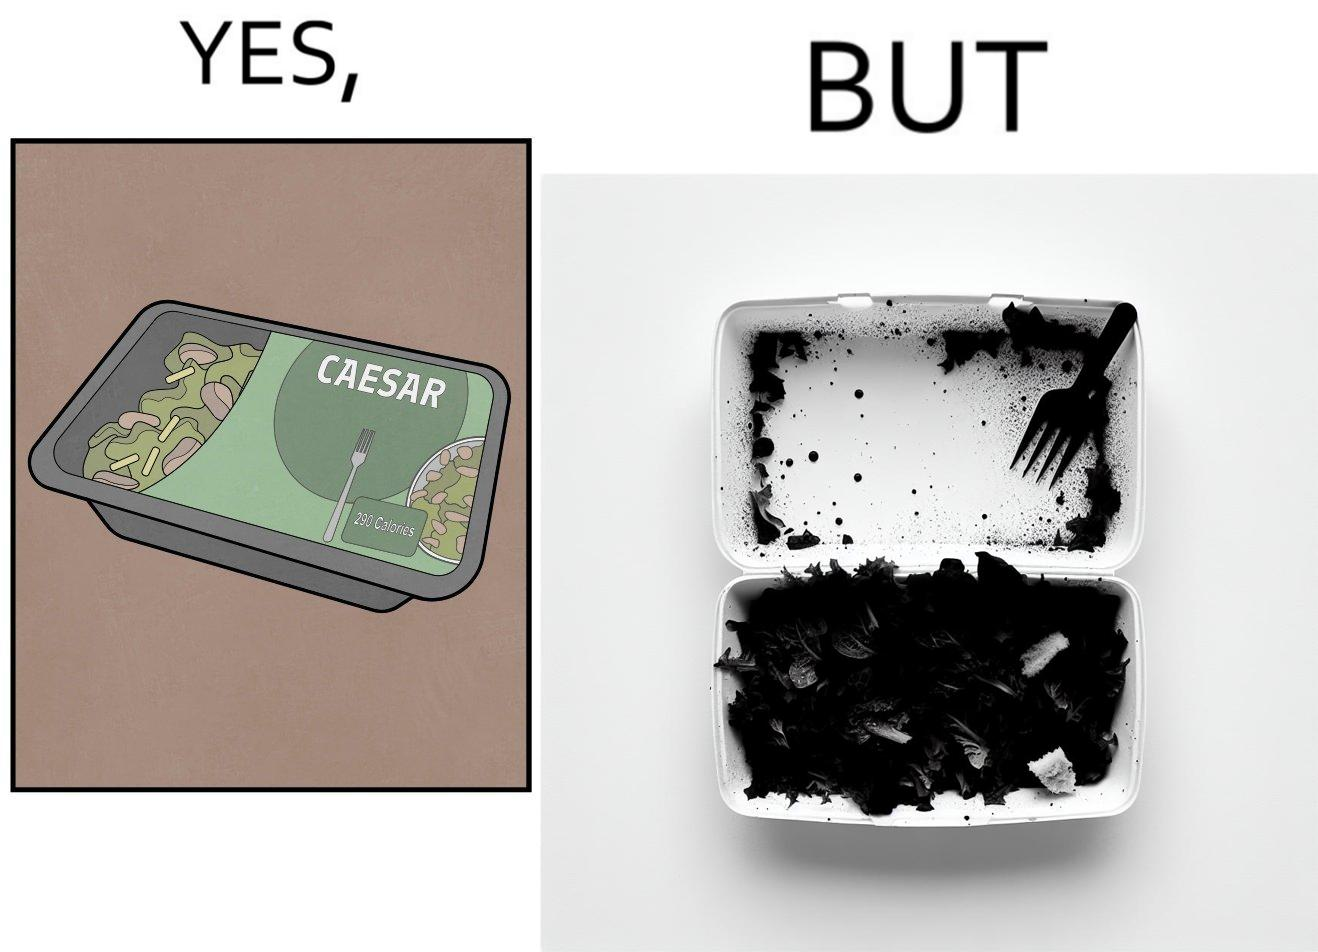Is this a satirical image? Yes, this image is satirical. 